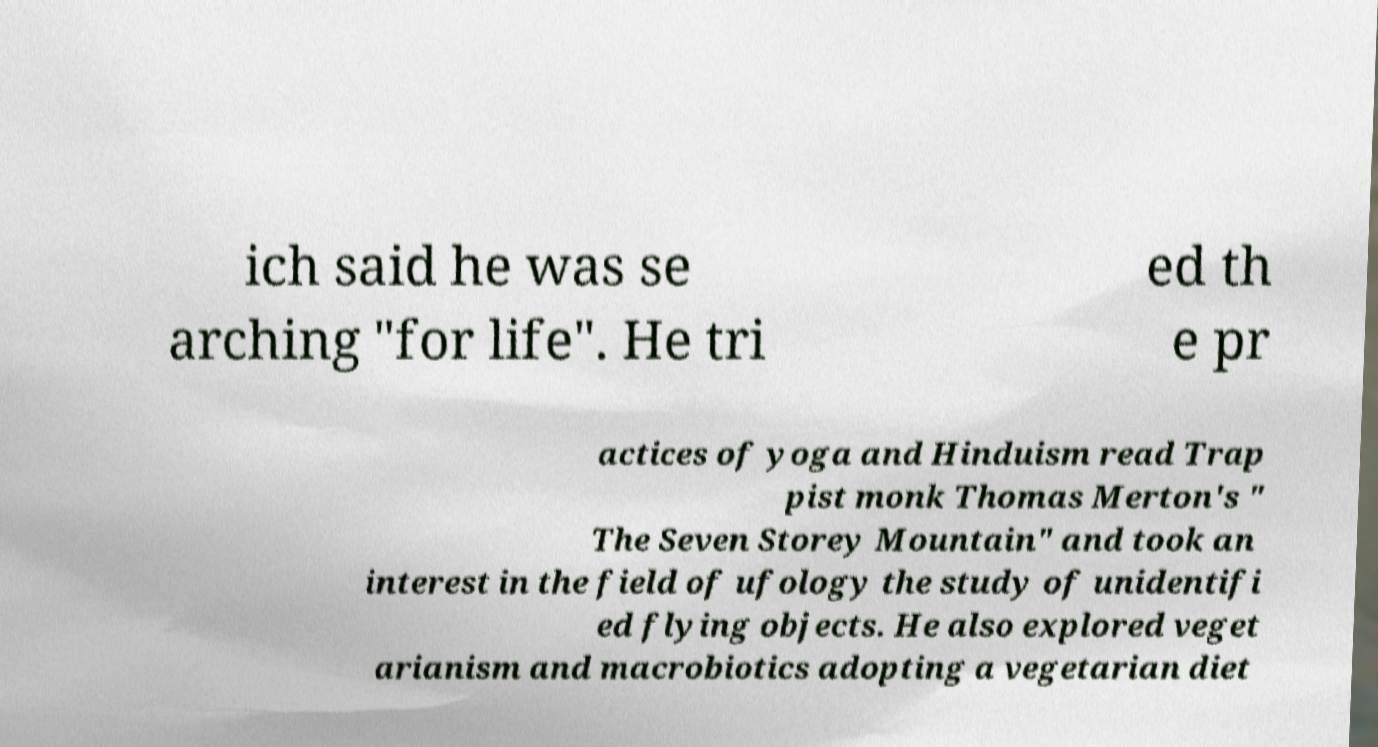Could you assist in decoding the text presented in this image and type it out clearly? ich said he was se arching "for life". He tri ed th e pr actices of yoga and Hinduism read Trap pist monk Thomas Merton's " The Seven Storey Mountain" and took an interest in the field of ufology the study of unidentifi ed flying objects. He also explored veget arianism and macrobiotics adopting a vegetarian diet 